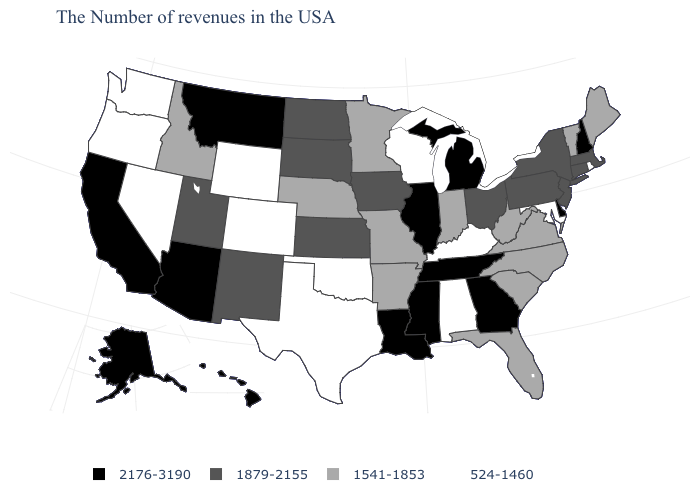What is the value of Iowa?
Keep it brief. 1879-2155. Which states hav the highest value in the West?
Concise answer only. Montana, Arizona, California, Alaska, Hawaii. What is the value of Wyoming?
Keep it brief. 524-1460. What is the highest value in the USA?
Be succinct. 2176-3190. What is the value of Indiana?
Short answer required. 1541-1853. What is the lowest value in states that border New York?
Answer briefly. 1541-1853. Which states hav the highest value in the Northeast?
Quick response, please. New Hampshire. Does Maryland have the highest value in the USA?
Short answer required. No. What is the value of Alabama?
Short answer required. 524-1460. What is the lowest value in the Northeast?
Short answer required. 524-1460. What is the value of Nevada?
Be succinct. 524-1460. Name the states that have a value in the range 1879-2155?
Short answer required. Massachusetts, Connecticut, New York, New Jersey, Pennsylvania, Ohio, Iowa, Kansas, South Dakota, North Dakota, New Mexico, Utah. Among the states that border Wyoming , does Utah have the highest value?
Quick response, please. No. Name the states that have a value in the range 2176-3190?
Be succinct. New Hampshire, Delaware, Georgia, Michigan, Tennessee, Illinois, Mississippi, Louisiana, Montana, Arizona, California, Alaska, Hawaii. What is the highest value in the USA?
Write a very short answer. 2176-3190. 